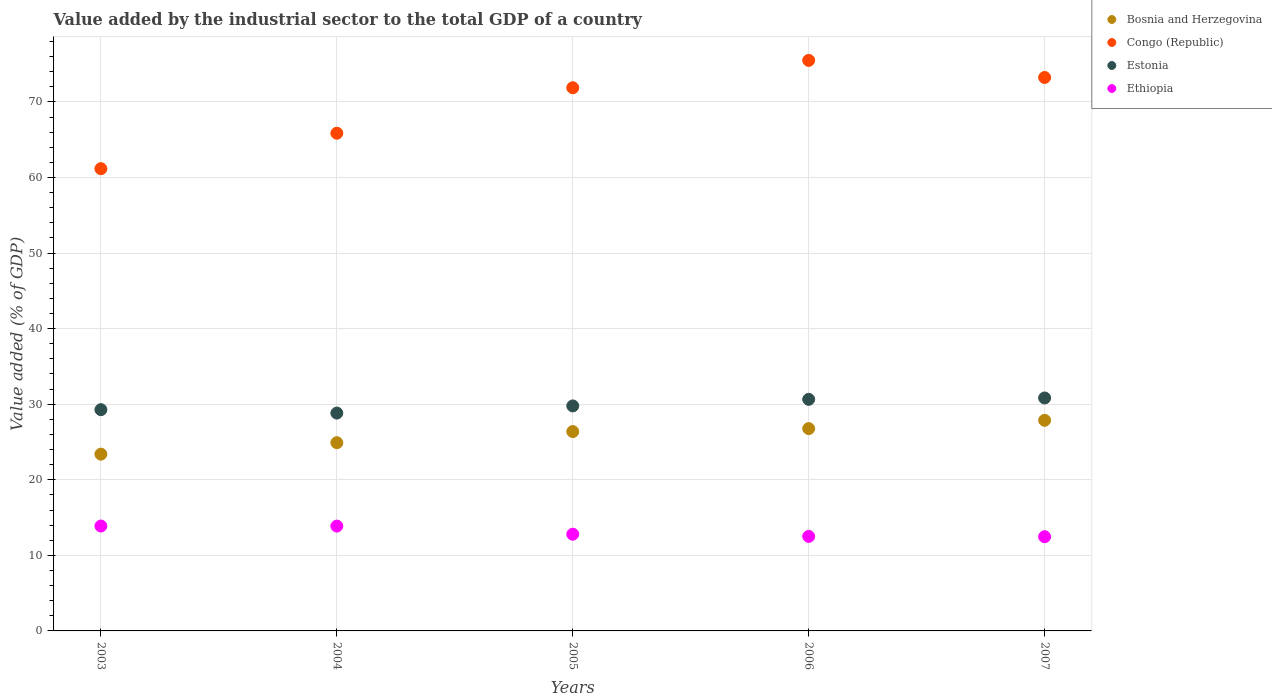How many different coloured dotlines are there?
Provide a short and direct response. 4. Is the number of dotlines equal to the number of legend labels?
Keep it short and to the point. Yes. What is the value added by the industrial sector to the total GDP in Ethiopia in 2004?
Provide a succinct answer. 13.87. Across all years, what is the maximum value added by the industrial sector to the total GDP in Bosnia and Herzegovina?
Your answer should be compact. 27.87. Across all years, what is the minimum value added by the industrial sector to the total GDP in Ethiopia?
Offer a very short reply. 12.47. In which year was the value added by the industrial sector to the total GDP in Congo (Republic) minimum?
Provide a short and direct response. 2003. What is the total value added by the industrial sector to the total GDP in Ethiopia in the graph?
Keep it short and to the point. 65.52. What is the difference between the value added by the industrial sector to the total GDP in Bosnia and Herzegovina in 2003 and that in 2006?
Give a very brief answer. -3.38. What is the difference between the value added by the industrial sector to the total GDP in Congo (Republic) in 2006 and the value added by the industrial sector to the total GDP in Ethiopia in 2007?
Offer a terse response. 63.03. What is the average value added by the industrial sector to the total GDP in Ethiopia per year?
Keep it short and to the point. 13.1. In the year 2006, what is the difference between the value added by the industrial sector to the total GDP in Ethiopia and value added by the industrial sector to the total GDP in Bosnia and Herzegovina?
Keep it short and to the point. -14.27. What is the ratio of the value added by the industrial sector to the total GDP in Bosnia and Herzegovina in 2004 to that in 2005?
Your answer should be compact. 0.94. Is the value added by the industrial sector to the total GDP in Ethiopia in 2005 less than that in 2007?
Your answer should be compact. No. What is the difference between the highest and the second highest value added by the industrial sector to the total GDP in Congo (Republic)?
Offer a very short reply. 2.26. What is the difference between the highest and the lowest value added by the industrial sector to the total GDP in Estonia?
Keep it short and to the point. 2. In how many years, is the value added by the industrial sector to the total GDP in Ethiopia greater than the average value added by the industrial sector to the total GDP in Ethiopia taken over all years?
Make the answer very short. 2. Is it the case that in every year, the sum of the value added by the industrial sector to the total GDP in Bosnia and Herzegovina and value added by the industrial sector to the total GDP in Estonia  is greater than the sum of value added by the industrial sector to the total GDP in Congo (Republic) and value added by the industrial sector to the total GDP in Ethiopia?
Give a very brief answer. Yes. Does the value added by the industrial sector to the total GDP in Bosnia and Herzegovina monotonically increase over the years?
Give a very brief answer. Yes. How many dotlines are there?
Your response must be concise. 4. How many years are there in the graph?
Ensure brevity in your answer.  5. Are the values on the major ticks of Y-axis written in scientific E-notation?
Keep it short and to the point. No. Where does the legend appear in the graph?
Offer a terse response. Top right. How many legend labels are there?
Your response must be concise. 4. How are the legend labels stacked?
Give a very brief answer. Vertical. What is the title of the graph?
Offer a very short reply. Value added by the industrial sector to the total GDP of a country. Does "Seychelles" appear as one of the legend labels in the graph?
Your answer should be compact. No. What is the label or title of the Y-axis?
Your response must be concise. Value added (% of GDP). What is the Value added (% of GDP) of Bosnia and Herzegovina in 2003?
Keep it short and to the point. 23.39. What is the Value added (% of GDP) in Congo (Republic) in 2003?
Offer a terse response. 61.17. What is the Value added (% of GDP) of Estonia in 2003?
Your response must be concise. 29.28. What is the Value added (% of GDP) of Ethiopia in 2003?
Offer a terse response. 13.88. What is the Value added (% of GDP) of Bosnia and Herzegovina in 2004?
Your response must be concise. 24.91. What is the Value added (% of GDP) of Congo (Republic) in 2004?
Provide a short and direct response. 65.86. What is the Value added (% of GDP) of Estonia in 2004?
Keep it short and to the point. 28.83. What is the Value added (% of GDP) of Ethiopia in 2004?
Your answer should be very brief. 13.87. What is the Value added (% of GDP) in Bosnia and Herzegovina in 2005?
Offer a terse response. 26.38. What is the Value added (% of GDP) of Congo (Republic) in 2005?
Your answer should be very brief. 71.88. What is the Value added (% of GDP) of Estonia in 2005?
Your answer should be very brief. 29.78. What is the Value added (% of GDP) in Ethiopia in 2005?
Your response must be concise. 12.8. What is the Value added (% of GDP) of Bosnia and Herzegovina in 2006?
Provide a succinct answer. 26.77. What is the Value added (% of GDP) of Congo (Republic) in 2006?
Give a very brief answer. 75.5. What is the Value added (% of GDP) in Estonia in 2006?
Give a very brief answer. 30.64. What is the Value added (% of GDP) of Ethiopia in 2006?
Give a very brief answer. 12.51. What is the Value added (% of GDP) in Bosnia and Herzegovina in 2007?
Keep it short and to the point. 27.87. What is the Value added (% of GDP) of Congo (Republic) in 2007?
Provide a succinct answer. 73.24. What is the Value added (% of GDP) of Estonia in 2007?
Provide a short and direct response. 30.83. What is the Value added (% of GDP) in Ethiopia in 2007?
Make the answer very short. 12.47. Across all years, what is the maximum Value added (% of GDP) of Bosnia and Herzegovina?
Keep it short and to the point. 27.87. Across all years, what is the maximum Value added (% of GDP) of Congo (Republic)?
Your answer should be compact. 75.5. Across all years, what is the maximum Value added (% of GDP) of Estonia?
Give a very brief answer. 30.83. Across all years, what is the maximum Value added (% of GDP) in Ethiopia?
Provide a short and direct response. 13.88. Across all years, what is the minimum Value added (% of GDP) of Bosnia and Herzegovina?
Provide a succinct answer. 23.39. Across all years, what is the minimum Value added (% of GDP) of Congo (Republic)?
Your answer should be very brief. 61.17. Across all years, what is the minimum Value added (% of GDP) in Estonia?
Keep it short and to the point. 28.83. Across all years, what is the minimum Value added (% of GDP) in Ethiopia?
Provide a succinct answer. 12.47. What is the total Value added (% of GDP) of Bosnia and Herzegovina in the graph?
Your answer should be very brief. 129.33. What is the total Value added (% of GDP) in Congo (Republic) in the graph?
Provide a succinct answer. 347.66. What is the total Value added (% of GDP) of Estonia in the graph?
Give a very brief answer. 149.35. What is the total Value added (% of GDP) in Ethiopia in the graph?
Keep it short and to the point. 65.53. What is the difference between the Value added (% of GDP) in Bosnia and Herzegovina in 2003 and that in 2004?
Your answer should be compact. -1.52. What is the difference between the Value added (% of GDP) in Congo (Republic) in 2003 and that in 2004?
Your response must be concise. -4.69. What is the difference between the Value added (% of GDP) in Estonia in 2003 and that in 2004?
Provide a succinct answer. 0.45. What is the difference between the Value added (% of GDP) in Ethiopia in 2003 and that in 2004?
Ensure brevity in your answer.  0.01. What is the difference between the Value added (% of GDP) in Bosnia and Herzegovina in 2003 and that in 2005?
Provide a short and direct response. -2.99. What is the difference between the Value added (% of GDP) of Congo (Republic) in 2003 and that in 2005?
Ensure brevity in your answer.  -10.71. What is the difference between the Value added (% of GDP) of Estonia in 2003 and that in 2005?
Provide a succinct answer. -0.5. What is the difference between the Value added (% of GDP) of Ethiopia in 2003 and that in 2005?
Give a very brief answer. 1.08. What is the difference between the Value added (% of GDP) of Bosnia and Herzegovina in 2003 and that in 2006?
Provide a succinct answer. -3.38. What is the difference between the Value added (% of GDP) in Congo (Republic) in 2003 and that in 2006?
Provide a short and direct response. -14.33. What is the difference between the Value added (% of GDP) in Estonia in 2003 and that in 2006?
Provide a short and direct response. -1.37. What is the difference between the Value added (% of GDP) in Ethiopia in 2003 and that in 2006?
Your response must be concise. 1.37. What is the difference between the Value added (% of GDP) of Bosnia and Herzegovina in 2003 and that in 2007?
Make the answer very short. -4.48. What is the difference between the Value added (% of GDP) of Congo (Republic) in 2003 and that in 2007?
Offer a terse response. -12.07. What is the difference between the Value added (% of GDP) of Estonia in 2003 and that in 2007?
Your response must be concise. -1.55. What is the difference between the Value added (% of GDP) in Ethiopia in 2003 and that in 2007?
Provide a succinct answer. 1.41. What is the difference between the Value added (% of GDP) of Bosnia and Herzegovina in 2004 and that in 2005?
Give a very brief answer. -1.47. What is the difference between the Value added (% of GDP) of Congo (Republic) in 2004 and that in 2005?
Offer a very short reply. -6.02. What is the difference between the Value added (% of GDP) of Estonia in 2004 and that in 2005?
Keep it short and to the point. -0.95. What is the difference between the Value added (% of GDP) in Ethiopia in 2004 and that in 2005?
Your response must be concise. 1.07. What is the difference between the Value added (% of GDP) of Bosnia and Herzegovina in 2004 and that in 2006?
Keep it short and to the point. -1.86. What is the difference between the Value added (% of GDP) of Congo (Republic) in 2004 and that in 2006?
Provide a short and direct response. -9.64. What is the difference between the Value added (% of GDP) of Estonia in 2004 and that in 2006?
Your response must be concise. -1.82. What is the difference between the Value added (% of GDP) of Ethiopia in 2004 and that in 2006?
Give a very brief answer. 1.37. What is the difference between the Value added (% of GDP) in Bosnia and Herzegovina in 2004 and that in 2007?
Give a very brief answer. -2.96. What is the difference between the Value added (% of GDP) in Congo (Republic) in 2004 and that in 2007?
Your answer should be very brief. -7.38. What is the difference between the Value added (% of GDP) in Estonia in 2004 and that in 2007?
Provide a succinct answer. -2. What is the difference between the Value added (% of GDP) in Ethiopia in 2004 and that in 2007?
Make the answer very short. 1.41. What is the difference between the Value added (% of GDP) in Bosnia and Herzegovina in 2005 and that in 2006?
Provide a succinct answer. -0.39. What is the difference between the Value added (% of GDP) in Congo (Republic) in 2005 and that in 2006?
Your answer should be very brief. -3.62. What is the difference between the Value added (% of GDP) of Estonia in 2005 and that in 2006?
Your answer should be very brief. -0.87. What is the difference between the Value added (% of GDP) in Ethiopia in 2005 and that in 2006?
Your answer should be very brief. 0.29. What is the difference between the Value added (% of GDP) of Bosnia and Herzegovina in 2005 and that in 2007?
Provide a succinct answer. -1.49. What is the difference between the Value added (% of GDP) in Congo (Republic) in 2005 and that in 2007?
Give a very brief answer. -1.36. What is the difference between the Value added (% of GDP) of Estonia in 2005 and that in 2007?
Keep it short and to the point. -1.05. What is the difference between the Value added (% of GDP) in Ethiopia in 2005 and that in 2007?
Give a very brief answer. 0.33. What is the difference between the Value added (% of GDP) of Bosnia and Herzegovina in 2006 and that in 2007?
Provide a short and direct response. -1.1. What is the difference between the Value added (% of GDP) in Congo (Republic) in 2006 and that in 2007?
Your response must be concise. 2.26. What is the difference between the Value added (% of GDP) in Estonia in 2006 and that in 2007?
Offer a terse response. -0.18. What is the difference between the Value added (% of GDP) in Ethiopia in 2006 and that in 2007?
Your response must be concise. 0.04. What is the difference between the Value added (% of GDP) in Bosnia and Herzegovina in 2003 and the Value added (% of GDP) in Congo (Republic) in 2004?
Keep it short and to the point. -42.47. What is the difference between the Value added (% of GDP) of Bosnia and Herzegovina in 2003 and the Value added (% of GDP) of Estonia in 2004?
Your response must be concise. -5.43. What is the difference between the Value added (% of GDP) of Bosnia and Herzegovina in 2003 and the Value added (% of GDP) of Ethiopia in 2004?
Offer a terse response. 9.52. What is the difference between the Value added (% of GDP) of Congo (Republic) in 2003 and the Value added (% of GDP) of Estonia in 2004?
Your answer should be very brief. 32.34. What is the difference between the Value added (% of GDP) of Congo (Republic) in 2003 and the Value added (% of GDP) of Ethiopia in 2004?
Provide a succinct answer. 47.3. What is the difference between the Value added (% of GDP) of Estonia in 2003 and the Value added (% of GDP) of Ethiopia in 2004?
Give a very brief answer. 15.4. What is the difference between the Value added (% of GDP) in Bosnia and Herzegovina in 2003 and the Value added (% of GDP) in Congo (Republic) in 2005?
Provide a succinct answer. -48.49. What is the difference between the Value added (% of GDP) of Bosnia and Herzegovina in 2003 and the Value added (% of GDP) of Estonia in 2005?
Give a very brief answer. -6.38. What is the difference between the Value added (% of GDP) in Bosnia and Herzegovina in 2003 and the Value added (% of GDP) in Ethiopia in 2005?
Make the answer very short. 10.6. What is the difference between the Value added (% of GDP) in Congo (Republic) in 2003 and the Value added (% of GDP) in Estonia in 2005?
Offer a very short reply. 31.4. What is the difference between the Value added (% of GDP) of Congo (Republic) in 2003 and the Value added (% of GDP) of Ethiopia in 2005?
Provide a succinct answer. 48.37. What is the difference between the Value added (% of GDP) of Estonia in 2003 and the Value added (% of GDP) of Ethiopia in 2005?
Your response must be concise. 16.48. What is the difference between the Value added (% of GDP) in Bosnia and Herzegovina in 2003 and the Value added (% of GDP) in Congo (Republic) in 2006?
Ensure brevity in your answer.  -52.11. What is the difference between the Value added (% of GDP) in Bosnia and Herzegovina in 2003 and the Value added (% of GDP) in Estonia in 2006?
Provide a short and direct response. -7.25. What is the difference between the Value added (% of GDP) in Bosnia and Herzegovina in 2003 and the Value added (% of GDP) in Ethiopia in 2006?
Your response must be concise. 10.89. What is the difference between the Value added (% of GDP) of Congo (Republic) in 2003 and the Value added (% of GDP) of Estonia in 2006?
Make the answer very short. 30.53. What is the difference between the Value added (% of GDP) in Congo (Republic) in 2003 and the Value added (% of GDP) in Ethiopia in 2006?
Offer a terse response. 48.67. What is the difference between the Value added (% of GDP) of Estonia in 2003 and the Value added (% of GDP) of Ethiopia in 2006?
Keep it short and to the point. 16.77. What is the difference between the Value added (% of GDP) in Bosnia and Herzegovina in 2003 and the Value added (% of GDP) in Congo (Republic) in 2007?
Your answer should be very brief. -49.85. What is the difference between the Value added (% of GDP) of Bosnia and Herzegovina in 2003 and the Value added (% of GDP) of Estonia in 2007?
Give a very brief answer. -7.43. What is the difference between the Value added (% of GDP) of Bosnia and Herzegovina in 2003 and the Value added (% of GDP) of Ethiopia in 2007?
Give a very brief answer. 10.93. What is the difference between the Value added (% of GDP) of Congo (Republic) in 2003 and the Value added (% of GDP) of Estonia in 2007?
Provide a short and direct response. 30.35. What is the difference between the Value added (% of GDP) in Congo (Republic) in 2003 and the Value added (% of GDP) in Ethiopia in 2007?
Provide a succinct answer. 48.71. What is the difference between the Value added (% of GDP) in Estonia in 2003 and the Value added (% of GDP) in Ethiopia in 2007?
Provide a succinct answer. 16.81. What is the difference between the Value added (% of GDP) of Bosnia and Herzegovina in 2004 and the Value added (% of GDP) of Congo (Republic) in 2005?
Provide a short and direct response. -46.97. What is the difference between the Value added (% of GDP) in Bosnia and Herzegovina in 2004 and the Value added (% of GDP) in Estonia in 2005?
Provide a short and direct response. -4.87. What is the difference between the Value added (% of GDP) in Bosnia and Herzegovina in 2004 and the Value added (% of GDP) in Ethiopia in 2005?
Your response must be concise. 12.11. What is the difference between the Value added (% of GDP) in Congo (Republic) in 2004 and the Value added (% of GDP) in Estonia in 2005?
Provide a short and direct response. 36.09. What is the difference between the Value added (% of GDP) of Congo (Republic) in 2004 and the Value added (% of GDP) of Ethiopia in 2005?
Give a very brief answer. 53.07. What is the difference between the Value added (% of GDP) in Estonia in 2004 and the Value added (% of GDP) in Ethiopia in 2005?
Provide a short and direct response. 16.03. What is the difference between the Value added (% of GDP) in Bosnia and Herzegovina in 2004 and the Value added (% of GDP) in Congo (Republic) in 2006?
Keep it short and to the point. -50.59. What is the difference between the Value added (% of GDP) in Bosnia and Herzegovina in 2004 and the Value added (% of GDP) in Estonia in 2006?
Provide a succinct answer. -5.74. What is the difference between the Value added (% of GDP) in Bosnia and Herzegovina in 2004 and the Value added (% of GDP) in Ethiopia in 2006?
Provide a succinct answer. 12.4. What is the difference between the Value added (% of GDP) of Congo (Republic) in 2004 and the Value added (% of GDP) of Estonia in 2006?
Make the answer very short. 35.22. What is the difference between the Value added (% of GDP) in Congo (Republic) in 2004 and the Value added (% of GDP) in Ethiopia in 2006?
Keep it short and to the point. 53.36. What is the difference between the Value added (% of GDP) of Estonia in 2004 and the Value added (% of GDP) of Ethiopia in 2006?
Your answer should be compact. 16.32. What is the difference between the Value added (% of GDP) of Bosnia and Herzegovina in 2004 and the Value added (% of GDP) of Congo (Republic) in 2007?
Your answer should be compact. -48.33. What is the difference between the Value added (% of GDP) in Bosnia and Herzegovina in 2004 and the Value added (% of GDP) in Estonia in 2007?
Your answer should be very brief. -5.92. What is the difference between the Value added (% of GDP) of Bosnia and Herzegovina in 2004 and the Value added (% of GDP) of Ethiopia in 2007?
Offer a terse response. 12.44. What is the difference between the Value added (% of GDP) in Congo (Republic) in 2004 and the Value added (% of GDP) in Estonia in 2007?
Your response must be concise. 35.04. What is the difference between the Value added (% of GDP) in Congo (Republic) in 2004 and the Value added (% of GDP) in Ethiopia in 2007?
Provide a succinct answer. 53.4. What is the difference between the Value added (% of GDP) of Estonia in 2004 and the Value added (% of GDP) of Ethiopia in 2007?
Provide a succinct answer. 16.36. What is the difference between the Value added (% of GDP) of Bosnia and Herzegovina in 2005 and the Value added (% of GDP) of Congo (Republic) in 2006?
Provide a succinct answer. -49.12. What is the difference between the Value added (% of GDP) in Bosnia and Herzegovina in 2005 and the Value added (% of GDP) in Estonia in 2006?
Your answer should be compact. -4.26. What is the difference between the Value added (% of GDP) of Bosnia and Herzegovina in 2005 and the Value added (% of GDP) of Ethiopia in 2006?
Offer a very short reply. 13.88. What is the difference between the Value added (% of GDP) in Congo (Republic) in 2005 and the Value added (% of GDP) in Estonia in 2006?
Ensure brevity in your answer.  41.24. What is the difference between the Value added (% of GDP) of Congo (Republic) in 2005 and the Value added (% of GDP) of Ethiopia in 2006?
Make the answer very short. 59.37. What is the difference between the Value added (% of GDP) of Estonia in 2005 and the Value added (% of GDP) of Ethiopia in 2006?
Your answer should be very brief. 17.27. What is the difference between the Value added (% of GDP) of Bosnia and Herzegovina in 2005 and the Value added (% of GDP) of Congo (Republic) in 2007?
Provide a succinct answer. -46.86. What is the difference between the Value added (% of GDP) of Bosnia and Herzegovina in 2005 and the Value added (% of GDP) of Estonia in 2007?
Keep it short and to the point. -4.44. What is the difference between the Value added (% of GDP) of Bosnia and Herzegovina in 2005 and the Value added (% of GDP) of Ethiopia in 2007?
Your response must be concise. 13.92. What is the difference between the Value added (% of GDP) in Congo (Republic) in 2005 and the Value added (% of GDP) in Estonia in 2007?
Your answer should be very brief. 41.06. What is the difference between the Value added (% of GDP) of Congo (Republic) in 2005 and the Value added (% of GDP) of Ethiopia in 2007?
Provide a succinct answer. 59.42. What is the difference between the Value added (% of GDP) in Estonia in 2005 and the Value added (% of GDP) in Ethiopia in 2007?
Your response must be concise. 17.31. What is the difference between the Value added (% of GDP) in Bosnia and Herzegovina in 2006 and the Value added (% of GDP) in Congo (Republic) in 2007?
Ensure brevity in your answer.  -46.47. What is the difference between the Value added (% of GDP) in Bosnia and Herzegovina in 2006 and the Value added (% of GDP) in Estonia in 2007?
Offer a very short reply. -4.05. What is the difference between the Value added (% of GDP) of Bosnia and Herzegovina in 2006 and the Value added (% of GDP) of Ethiopia in 2007?
Ensure brevity in your answer.  14.31. What is the difference between the Value added (% of GDP) of Congo (Republic) in 2006 and the Value added (% of GDP) of Estonia in 2007?
Your answer should be compact. 44.67. What is the difference between the Value added (% of GDP) in Congo (Republic) in 2006 and the Value added (% of GDP) in Ethiopia in 2007?
Keep it short and to the point. 63.03. What is the difference between the Value added (% of GDP) of Estonia in 2006 and the Value added (% of GDP) of Ethiopia in 2007?
Give a very brief answer. 18.18. What is the average Value added (% of GDP) in Bosnia and Herzegovina per year?
Your answer should be very brief. 25.87. What is the average Value added (% of GDP) in Congo (Republic) per year?
Your response must be concise. 69.53. What is the average Value added (% of GDP) in Estonia per year?
Your answer should be very brief. 29.87. What is the average Value added (% of GDP) of Ethiopia per year?
Keep it short and to the point. 13.11. In the year 2003, what is the difference between the Value added (% of GDP) in Bosnia and Herzegovina and Value added (% of GDP) in Congo (Republic)?
Give a very brief answer. -37.78. In the year 2003, what is the difference between the Value added (% of GDP) in Bosnia and Herzegovina and Value added (% of GDP) in Estonia?
Provide a short and direct response. -5.88. In the year 2003, what is the difference between the Value added (% of GDP) of Bosnia and Herzegovina and Value added (% of GDP) of Ethiopia?
Offer a very short reply. 9.51. In the year 2003, what is the difference between the Value added (% of GDP) in Congo (Republic) and Value added (% of GDP) in Estonia?
Offer a very short reply. 31.89. In the year 2003, what is the difference between the Value added (% of GDP) in Congo (Republic) and Value added (% of GDP) in Ethiopia?
Keep it short and to the point. 47.29. In the year 2003, what is the difference between the Value added (% of GDP) of Estonia and Value added (% of GDP) of Ethiopia?
Offer a very short reply. 15.4. In the year 2004, what is the difference between the Value added (% of GDP) in Bosnia and Herzegovina and Value added (% of GDP) in Congo (Republic)?
Your response must be concise. -40.95. In the year 2004, what is the difference between the Value added (% of GDP) in Bosnia and Herzegovina and Value added (% of GDP) in Estonia?
Your answer should be very brief. -3.92. In the year 2004, what is the difference between the Value added (% of GDP) in Bosnia and Herzegovina and Value added (% of GDP) in Ethiopia?
Your answer should be compact. 11.04. In the year 2004, what is the difference between the Value added (% of GDP) of Congo (Republic) and Value added (% of GDP) of Estonia?
Your answer should be very brief. 37.04. In the year 2004, what is the difference between the Value added (% of GDP) in Congo (Republic) and Value added (% of GDP) in Ethiopia?
Provide a succinct answer. 51.99. In the year 2004, what is the difference between the Value added (% of GDP) of Estonia and Value added (% of GDP) of Ethiopia?
Provide a succinct answer. 14.96. In the year 2005, what is the difference between the Value added (% of GDP) of Bosnia and Herzegovina and Value added (% of GDP) of Congo (Republic)?
Offer a very short reply. -45.5. In the year 2005, what is the difference between the Value added (% of GDP) in Bosnia and Herzegovina and Value added (% of GDP) in Estonia?
Give a very brief answer. -3.39. In the year 2005, what is the difference between the Value added (% of GDP) in Bosnia and Herzegovina and Value added (% of GDP) in Ethiopia?
Make the answer very short. 13.58. In the year 2005, what is the difference between the Value added (% of GDP) of Congo (Republic) and Value added (% of GDP) of Estonia?
Provide a short and direct response. 42.11. In the year 2005, what is the difference between the Value added (% of GDP) in Congo (Republic) and Value added (% of GDP) in Ethiopia?
Give a very brief answer. 59.08. In the year 2005, what is the difference between the Value added (% of GDP) in Estonia and Value added (% of GDP) in Ethiopia?
Keep it short and to the point. 16.98. In the year 2006, what is the difference between the Value added (% of GDP) of Bosnia and Herzegovina and Value added (% of GDP) of Congo (Republic)?
Your answer should be compact. -48.73. In the year 2006, what is the difference between the Value added (% of GDP) of Bosnia and Herzegovina and Value added (% of GDP) of Estonia?
Your response must be concise. -3.87. In the year 2006, what is the difference between the Value added (% of GDP) of Bosnia and Herzegovina and Value added (% of GDP) of Ethiopia?
Give a very brief answer. 14.27. In the year 2006, what is the difference between the Value added (% of GDP) in Congo (Republic) and Value added (% of GDP) in Estonia?
Your answer should be very brief. 44.86. In the year 2006, what is the difference between the Value added (% of GDP) in Congo (Republic) and Value added (% of GDP) in Ethiopia?
Provide a short and direct response. 62.99. In the year 2006, what is the difference between the Value added (% of GDP) in Estonia and Value added (% of GDP) in Ethiopia?
Ensure brevity in your answer.  18.14. In the year 2007, what is the difference between the Value added (% of GDP) in Bosnia and Herzegovina and Value added (% of GDP) in Congo (Republic)?
Provide a short and direct response. -45.37. In the year 2007, what is the difference between the Value added (% of GDP) of Bosnia and Herzegovina and Value added (% of GDP) of Estonia?
Offer a terse response. -2.96. In the year 2007, what is the difference between the Value added (% of GDP) of Bosnia and Herzegovina and Value added (% of GDP) of Ethiopia?
Provide a short and direct response. 15.4. In the year 2007, what is the difference between the Value added (% of GDP) of Congo (Republic) and Value added (% of GDP) of Estonia?
Provide a short and direct response. 42.41. In the year 2007, what is the difference between the Value added (% of GDP) of Congo (Republic) and Value added (% of GDP) of Ethiopia?
Offer a terse response. 60.77. In the year 2007, what is the difference between the Value added (% of GDP) in Estonia and Value added (% of GDP) in Ethiopia?
Your answer should be very brief. 18.36. What is the ratio of the Value added (% of GDP) of Bosnia and Herzegovina in 2003 to that in 2004?
Make the answer very short. 0.94. What is the ratio of the Value added (% of GDP) of Congo (Republic) in 2003 to that in 2004?
Your response must be concise. 0.93. What is the ratio of the Value added (% of GDP) of Estonia in 2003 to that in 2004?
Offer a very short reply. 1.02. What is the ratio of the Value added (% of GDP) of Bosnia and Herzegovina in 2003 to that in 2005?
Ensure brevity in your answer.  0.89. What is the ratio of the Value added (% of GDP) of Congo (Republic) in 2003 to that in 2005?
Your response must be concise. 0.85. What is the ratio of the Value added (% of GDP) in Estonia in 2003 to that in 2005?
Offer a terse response. 0.98. What is the ratio of the Value added (% of GDP) in Ethiopia in 2003 to that in 2005?
Provide a short and direct response. 1.08. What is the ratio of the Value added (% of GDP) in Bosnia and Herzegovina in 2003 to that in 2006?
Offer a very short reply. 0.87. What is the ratio of the Value added (% of GDP) of Congo (Republic) in 2003 to that in 2006?
Offer a terse response. 0.81. What is the ratio of the Value added (% of GDP) in Estonia in 2003 to that in 2006?
Provide a succinct answer. 0.96. What is the ratio of the Value added (% of GDP) in Ethiopia in 2003 to that in 2006?
Ensure brevity in your answer.  1.11. What is the ratio of the Value added (% of GDP) of Bosnia and Herzegovina in 2003 to that in 2007?
Give a very brief answer. 0.84. What is the ratio of the Value added (% of GDP) in Congo (Republic) in 2003 to that in 2007?
Ensure brevity in your answer.  0.84. What is the ratio of the Value added (% of GDP) in Estonia in 2003 to that in 2007?
Provide a succinct answer. 0.95. What is the ratio of the Value added (% of GDP) of Ethiopia in 2003 to that in 2007?
Keep it short and to the point. 1.11. What is the ratio of the Value added (% of GDP) in Bosnia and Herzegovina in 2004 to that in 2005?
Offer a very short reply. 0.94. What is the ratio of the Value added (% of GDP) in Congo (Republic) in 2004 to that in 2005?
Keep it short and to the point. 0.92. What is the ratio of the Value added (% of GDP) of Estonia in 2004 to that in 2005?
Your answer should be very brief. 0.97. What is the ratio of the Value added (% of GDP) in Ethiopia in 2004 to that in 2005?
Offer a very short reply. 1.08. What is the ratio of the Value added (% of GDP) of Bosnia and Herzegovina in 2004 to that in 2006?
Give a very brief answer. 0.93. What is the ratio of the Value added (% of GDP) of Congo (Republic) in 2004 to that in 2006?
Provide a short and direct response. 0.87. What is the ratio of the Value added (% of GDP) of Estonia in 2004 to that in 2006?
Your response must be concise. 0.94. What is the ratio of the Value added (% of GDP) of Ethiopia in 2004 to that in 2006?
Provide a short and direct response. 1.11. What is the ratio of the Value added (% of GDP) in Bosnia and Herzegovina in 2004 to that in 2007?
Your answer should be compact. 0.89. What is the ratio of the Value added (% of GDP) of Congo (Republic) in 2004 to that in 2007?
Your response must be concise. 0.9. What is the ratio of the Value added (% of GDP) of Estonia in 2004 to that in 2007?
Ensure brevity in your answer.  0.94. What is the ratio of the Value added (% of GDP) in Ethiopia in 2004 to that in 2007?
Keep it short and to the point. 1.11. What is the ratio of the Value added (% of GDP) of Bosnia and Herzegovina in 2005 to that in 2006?
Your response must be concise. 0.99. What is the ratio of the Value added (% of GDP) in Congo (Republic) in 2005 to that in 2006?
Your answer should be compact. 0.95. What is the ratio of the Value added (% of GDP) in Estonia in 2005 to that in 2006?
Offer a very short reply. 0.97. What is the ratio of the Value added (% of GDP) of Ethiopia in 2005 to that in 2006?
Provide a short and direct response. 1.02. What is the ratio of the Value added (% of GDP) of Bosnia and Herzegovina in 2005 to that in 2007?
Offer a terse response. 0.95. What is the ratio of the Value added (% of GDP) in Congo (Republic) in 2005 to that in 2007?
Your response must be concise. 0.98. What is the ratio of the Value added (% of GDP) of Estonia in 2005 to that in 2007?
Make the answer very short. 0.97. What is the ratio of the Value added (% of GDP) in Ethiopia in 2005 to that in 2007?
Provide a succinct answer. 1.03. What is the ratio of the Value added (% of GDP) of Bosnia and Herzegovina in 2006 to that in 2007?
Give a very brief answer. 0.96. What is the ratio of the Value added (% of GDP) in Congo (Republic) in 2006 to that in 2007?
Your response must be concise. 1.03. What is the ratio of the Value added (% of GDP) of Ethiopia in 2006 to that in 2007?
Make the answer very short. 1. What is the difference between the highest and the second highest Value added (% of GDP) in Bosnia and Herzegovina?
Provide a succinct answer. 1.1. What is the difference between the highest and the second highest Value added (% of GDP) in Congo (Republic)?
Provide a succinct answer. 2.26. What is the difference between the highest and the second highest Value added (% of GDP) in Estonia?
Offer a very short reply. 0.18. What is the difference between the highest and the second highest Value added (% of GDP) in Ethiopia?
Ensure brevity in your answer.  0.01. What is the difference between the highest and the lowest Value added (% of GDP) in Bosnia and Herzegovina?
Your answer should be compact. 4.48. What is the difference between the highest and the lowest Value added (% of GDP) of Congo (Republic)?
Keep it short and to the point. 14.33. What is the difference between the highest and the lowest Value added (% of GDP) of Estonia?
Ensure brevity in your answer.  2. What is the difference between the highest and the lowest Value added (% of GDP) in Ethiopia?
Give a very brief answer. 1.41. 